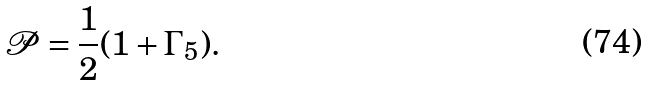<formula> <loc_0><loc_0><loc_500><loc_500>\mathcal { P } = \frac { 1 } { 2 } ( 1 + \Gamma _ { 5 } ) .</formula> 